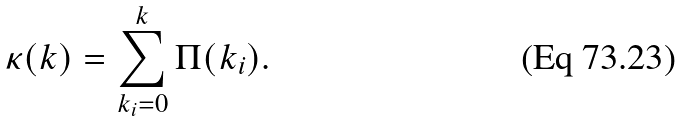<formula> <loc_0><loc_0><loc_500><loc_500>\kappa ( k ) = \sum _ { k _ { i } = 0 } ^ { k } \Pi ( k _ { i } ) .</formula> 